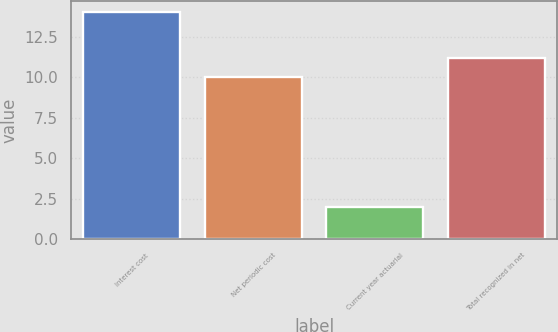Convert chart to OTSL. <chart><loc_0><loc_0><loc_500><loc_500><bar_chart><fcel>Interest cost<fcel>Net periodic cost<fcel>Current year actuarial<fcel>Total recognized in net<nl><fcel>14<fcel>10<fcel>2<fcel>11.2<nl></chart> 